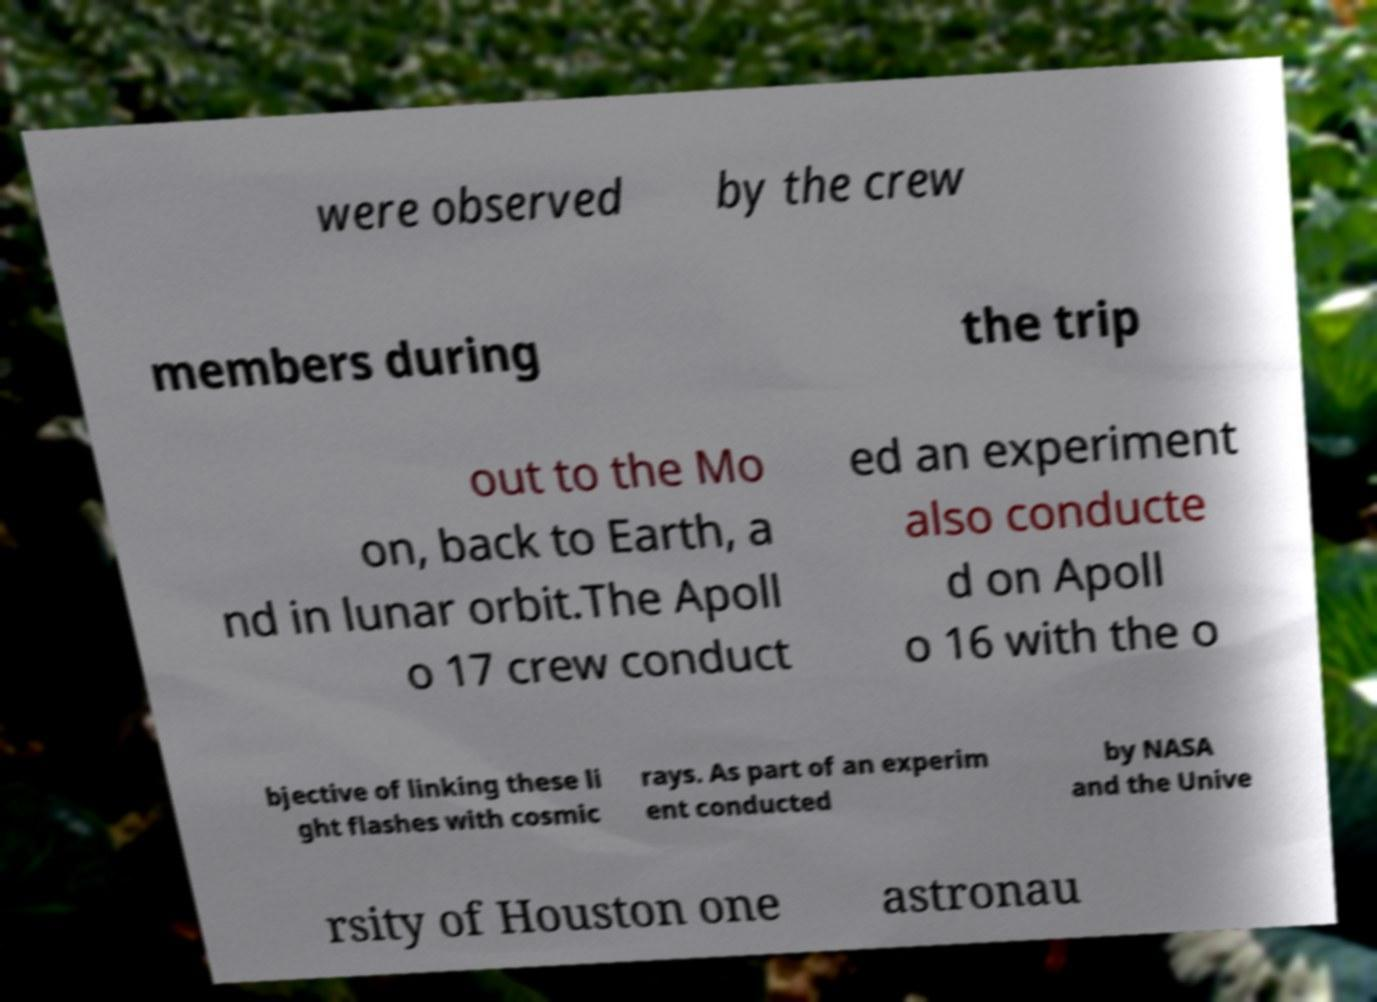Please identify and transcribe the text found in this image. were observed by the crew members during the trip out to the Mo on, back to Earth, a nd in lunar orbit.The Apoll o 17 crew conduct ed an experiment also conducte d on Apoll o 16 with the o bjective of linking these li ght flashes with cosmic rays. As part of an experim ent conducted by NASA and the Unive rsity of Houston one astronau 